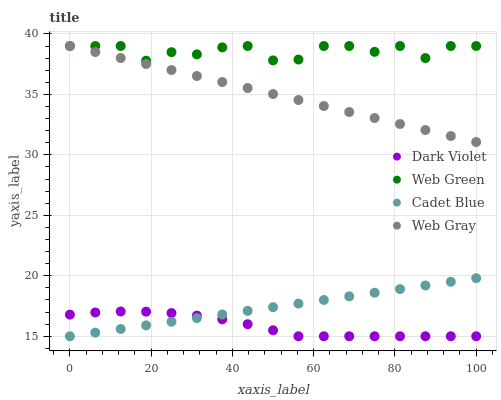Does Dark Violet have the minimum area under the curve?
Answer yes or no. Yes. Does Web Green have the maximum area under the curve?
Answer yes or no. Yes. Does Web Gray have the minimum area under the curve?
Answer yes or no. No. Does Web Gray have the maximum area under the curve?
Answer yes or no. No. Is Web Gray the smoothest?
Answer yes or no. Yes. Is Web Green the roughest?
Answer yes or no. Yes. Is Web Green the smoothest?
Answer yes or no. No. Is Web Gray the roughest?
Answer yes or no. No. Does Cadet Blue have the lowest value?
Answer yes or no. Yes. Does Web Gray have the lowest value?
Answer yes or no. No. Does Web Green have the highest value?
Answer yes or no. Yes. Does Dark Violet have the highest value?
Answer yes or no. No. Is Dark Violet less than Web Green?
Answer yes or no. Yes. Is Web Gray greater than Cadet Blue?
Answer yes or no. Yes. Does Web Green intersect Web Gray?
Answer yes or no. Yes. Is Web Green less than Web Gray?
Answer yes or no. No. Is Web Green greater than Web Gray?
Answer yes or no. No. Does Dark Violet intersect Web Green?
Answer yes or no. No. 